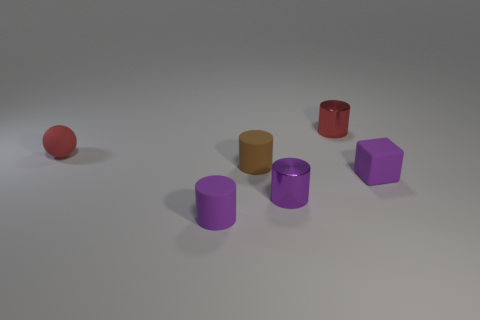Are there more tiny brown rubber cylinders behind the tiny block than small brown objects left of the tiny red sphere?
Make the answer very short. Yes. What number of objects are red cylinders right of the tiny brown cylinder or blocks?
Your response must be concise. 2. There is a small brown object that is the same material as the small sphere; what shape is it?
Provide a succinct answer. Cylinder. Is there anything else that has the same shape as the purple shiny thing?
Provide a succinct answer. Yes. What is the color of the thing that is both in front of the red metal cylinder and behind the brown cylinder?
Your answer should be very brief. Red. How many balls are either tiny matte objects or purple things?
Ensure brevity in your answer.  1. What number of other rubber blocks are the same size as the purple block?
Keep it short and to the point. 0. What number of purple rubber things are right of the purple matte thing that is in front of the tiny rubber block?
Your response must be concise. 1. What size is the object that is behind the tiny brown object and right of the tiny matte sphere?
Make the answer very short. Small. Are there more big blue cubes than red objects?
Offer a very short reply. No. 